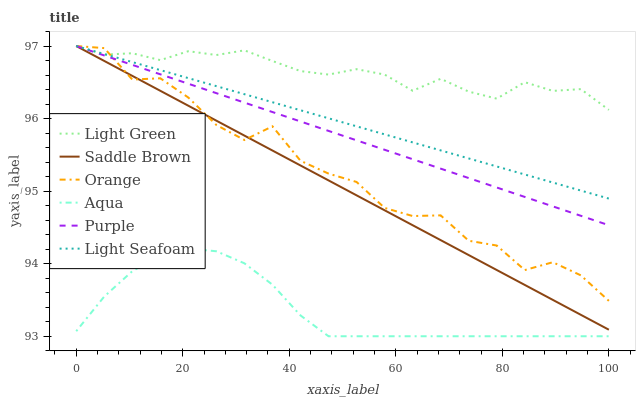Does Light Green have the minimum area under the curve?
Answer yes or no. No. Does Aqua have the maximum area under the curve?
Answer yes or no. No. Is Aqua the smoothest?
Answer yes or no. No. Is Aqua the roughest?
Answer yes or no. No. Does Light Green have the lowest value?
Answer yes or no. No. Does Aqua have the highest value?
Answer yes or no. No. Is Aqua less than Orange?
Answer yes or no. Yes. Is Light Green greater than Aqua?
Answer yes or no. Yes. Does Aqua intersect Orange?
Answer yes or no. No. 